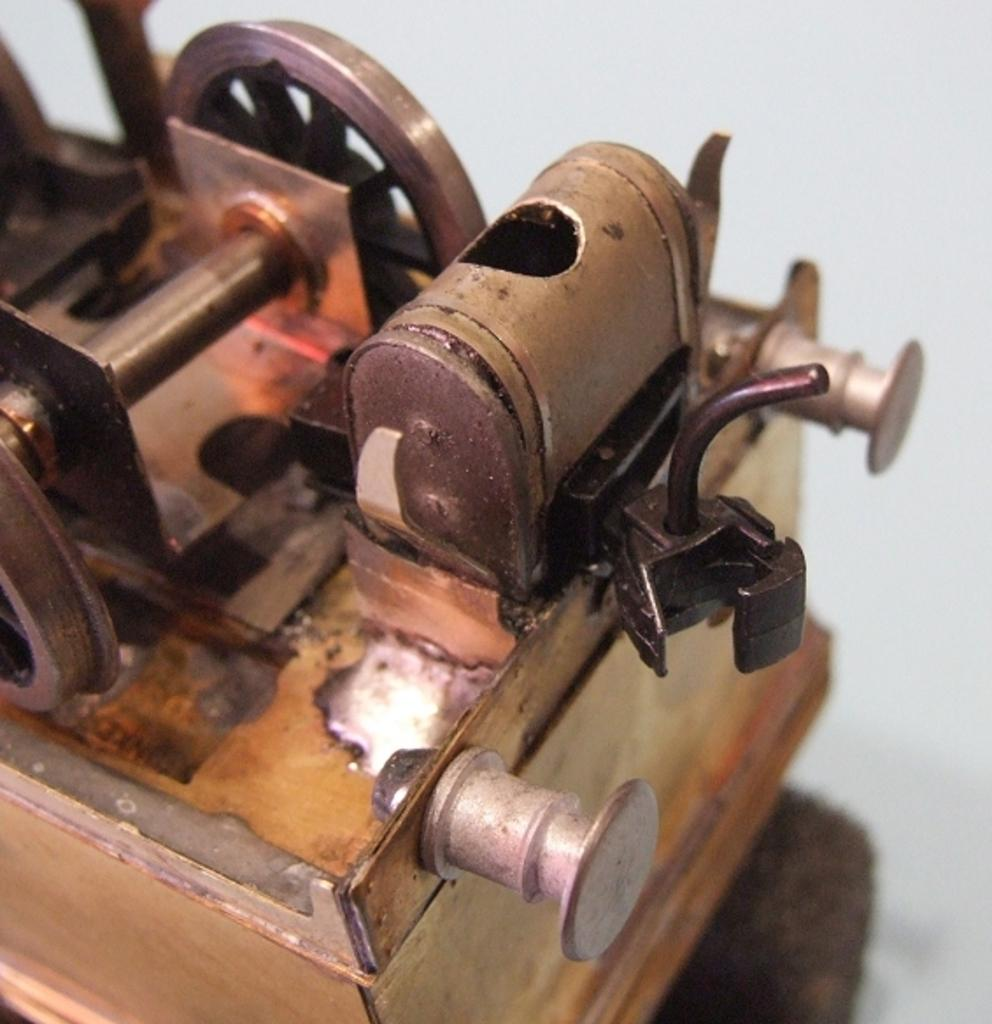What type of machine is in the image? There is a copper machine in the image. What color is the background of the image? The background of the image is white. What type of polish is being applied to the machine in the image? There is no indication of any polish being applied to the machine in the image. 